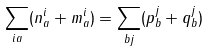Convert formula to latex. <formula><loc_0><loc_0><loc_500><loc_500>\sum _ { i a } ( n ^ { i } _ { a } + m ^ { i } _ { a } ) = \sum _ { b j } ( p ^ { j } _ { b } + q ^ { j } _ { b } )</formula> 